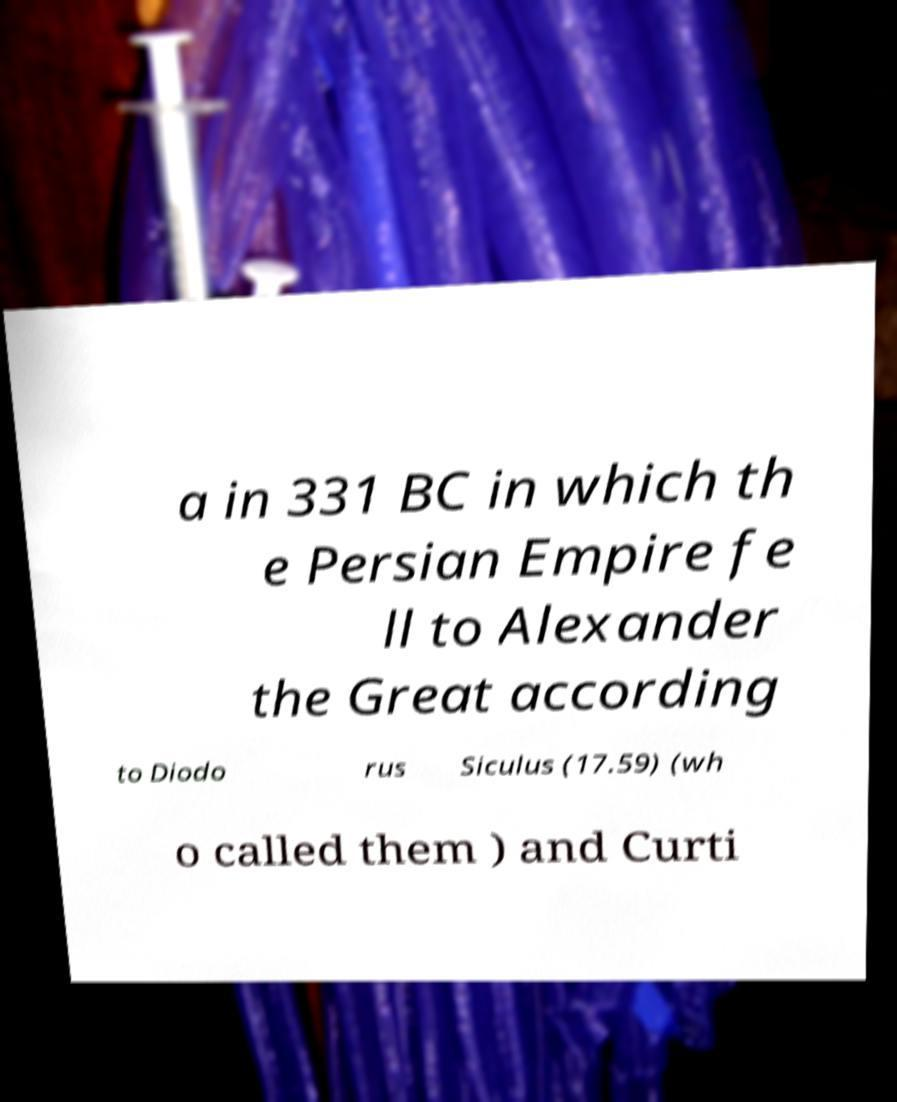Please identify and transcribe the text found in this image. a in 331 BC in which th e Persian Empire fe ll to Alexander the Great according to Diodo rus Siculus (17.59) (wh o called them ) and Curti 